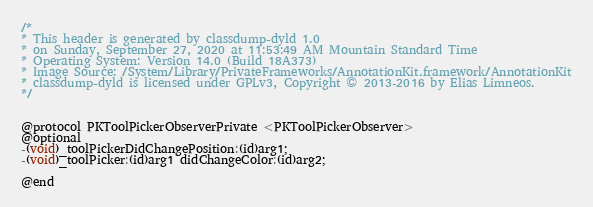<code> <loc_0><loc_0><loc_500><loc_500><_C_>/*
* This header is generated by classdump-dyld 1.0
* on Sunday, September 27, 2020 at 11:53:49 AM Mountain Standard Time
* Operating System: Version 14.0 (Build 18A373)
* Image Source: /System/Library/PrivateFrameworks/AnnotationKit.framework/AnnotationKit
* classdump-dyld is licensed under GPLv3, Copyright © 2013-2016 by Elias Limneos.
*/


@protocol PKToolPickerObserverPrivate <PKToolPickerObserver>
@optional
-(void)_toolPickerDidChangePosition:(id)arg1;
-(void)_toolPicker:(id)arg1 didChangeColor:(id)arg2;

@end

</code> 